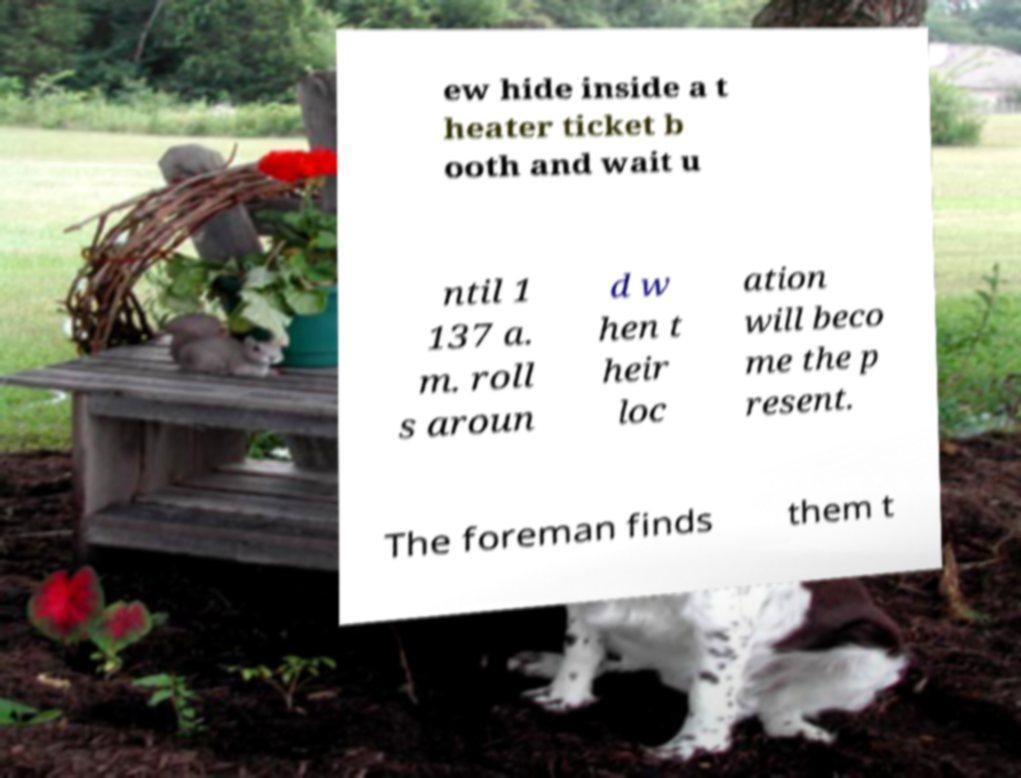Please identify and transcribe the text found in this image. ew hide inside a t heater ticket b ooth and wait u ntil 1 137 a. m. roll s aroun d w hen t heir loc ation will beco me the p resent. The foreman finds them t 